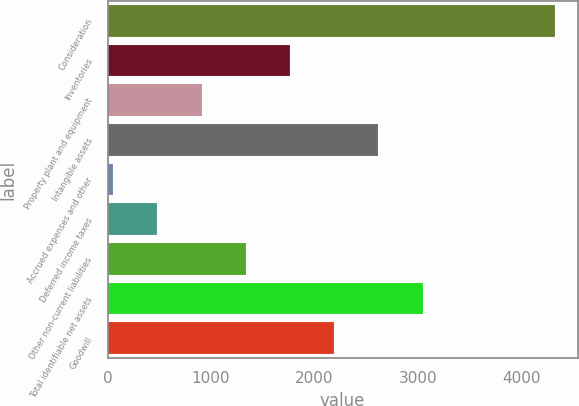Convert chart to OTSL. <chart><loc_0><loc_0><loc_500><loc_500><bar_chart><fcel>Consideration<fcel>Inventories<fcel>Property plant and equipment<fcel>Intangible assets<fcel>Accrued expenses and other<fcel>Deferred income taxes<fcel>Other non-current liabilities<fcel>Total identifiable net assets<fcel>Goodwill<nl><fcel>4330<fcel>1764.4<fcel>909.2<fcel>2619.6<fcel>54<fcel>481.6<fcel>1336.8<fcel>3047.2<fcel>2192<nl></chart> 